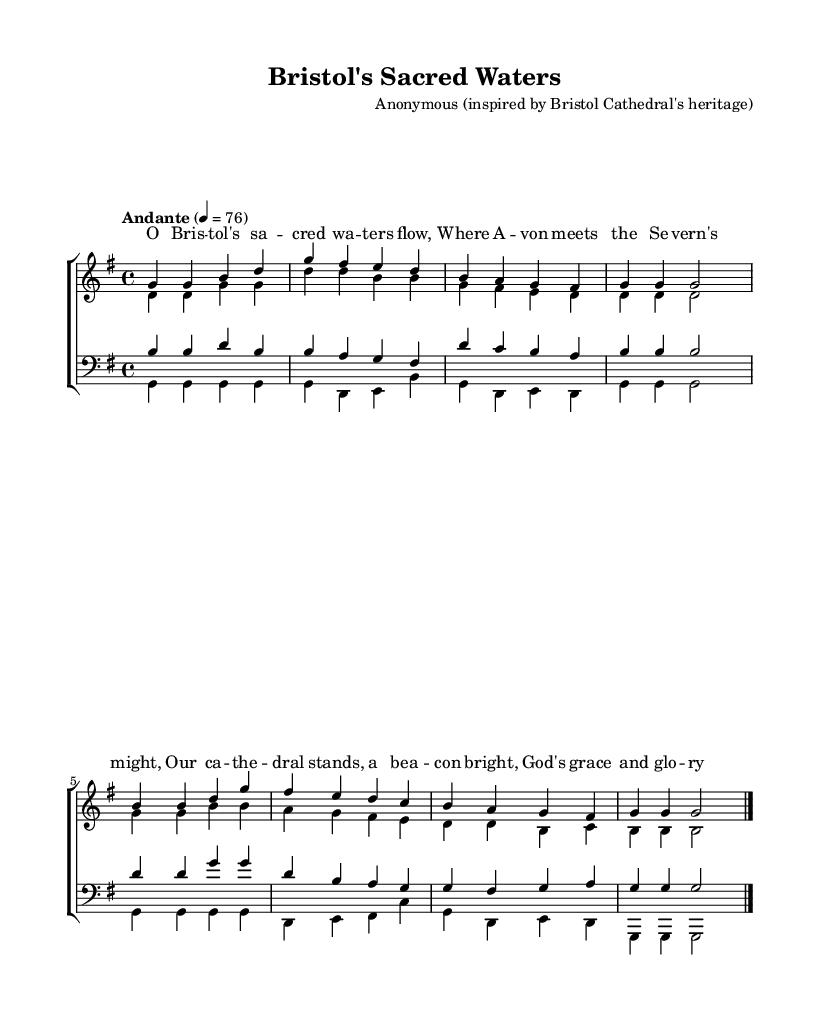What is the key signature of this music? The key signature is G major, which has one sharp (F sharp).
Answer: G major What is the time signature of this music? The time signature is 4/4, indicating four beats per measure.
Answer: 4/4 What is the tempo marking of this piece? The tempo marking is "Andante," which suggests a moderate walking pace.
Answer: Andante How many parts are in the choir? There are four parts in the choir: sopranos, altos, tenors, and basses.
Answer: Four What is the highest note in the soprano part? The highest note in the soprano part is D.
Answer: D What is the overall theme reflected in the lyrics? The overall theme reflects the heritage of Bristol and spirituality related to the cathedral.
Answer: Heritage How does the composition reflect religious traditions? The composition incorporates harmonies and lyrics that celebrate God's grace, typical of Anglican choral music.
Answer: Anglican choral music 